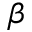<formula> <loc_0><loc_0><loc_500><loc_500>\beta</formula> 